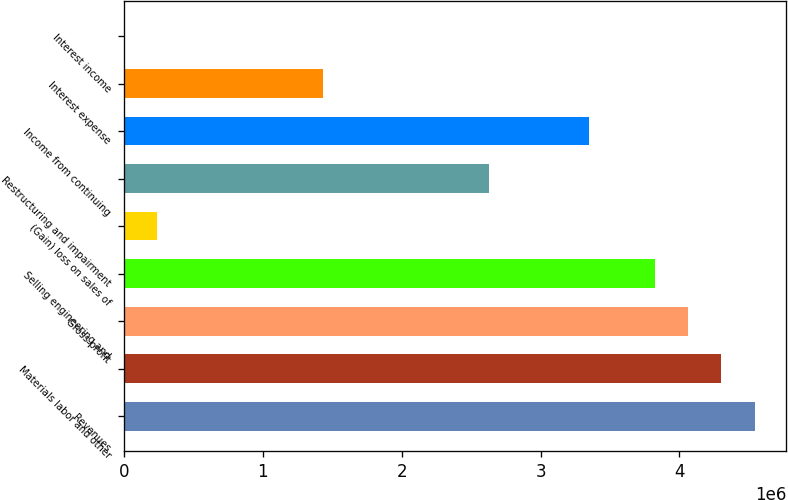Convert chart to OTSL. <chart><loc_0><loc_0><loc_500><loc_500><bar_chart><fcel>Revenues<fcel>Materials labor and other<fcel>Gross profit<fcel>Selling engineering and<fcel>(Gain) loss on sales of<fcel>Restructuring and impairment<fcel>Income from continuing<fcel>Interest expense<fcel>Interest income<nl><fcel>4.54127e+06<fcel>4.30229e+06<fcel>4.0633e+06<fcel>3.82432e+06<fcel>239550<fcel>2.6294e+06<fcel>3.34635e+06<fcel>1.43447e+06<fcel>565<nl></chart> 